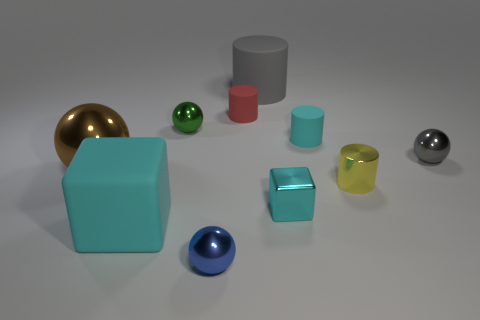Does the large cylinder have the same color as the sphere to the right of the red matte cylinder?
Ensure brevity in your answer.  Yes. There is a cyan block that is the same size as the gray ball; what is it made of?
Keep it short and to the point. Metal. How many objects are either large green matte objects or tiny metallic objects that are left of the small metallic cube?
Offer a very short reply. 2. Does the rubber block have the same size as the gray object left of the tiny yellow metallic cylinder?
Your response must be concise. Yes. How many cylinders are green metallic things or brown things?
Provide a short and direct response. 0. What number of small objects are both in front of the brown metal sphere and right of the cyan rubber cylinder?
Offer a very short reply. 1. How many other objects are there of the same color as the tiny cube?
Offer a very short reply. 2. What is the shape of the cyan rubber object to the left of the big gray rubber thing?
Ensure brevity in your answer.  Cube. Do the small gray sphere and the small red cylinder have the same material?
Ensure brevity in your answer.  No. What number of tiny matte cylinders are behind the tiny cyan cylinder?
Keep it short and to the point. 1. 